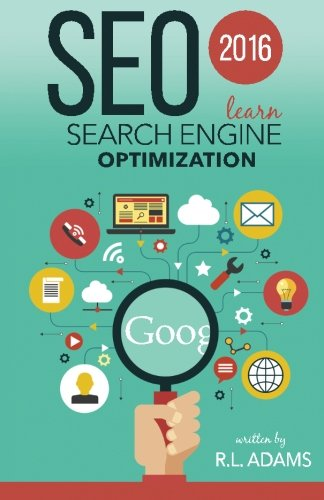Is this book suitable for beginners in the field of SEO? Yes, this book is designed to be accessible for beginners with a comprehensive introduction to the basics of SEO, making it a great starting point for those new to the field. Does it also benefit professionals with more experience? Absolutely, while it's beginner-friendly, the book also delves into advanced techniques that can benefit seasoned professionals looking to stay current with the latest SEO trends and tactics. 